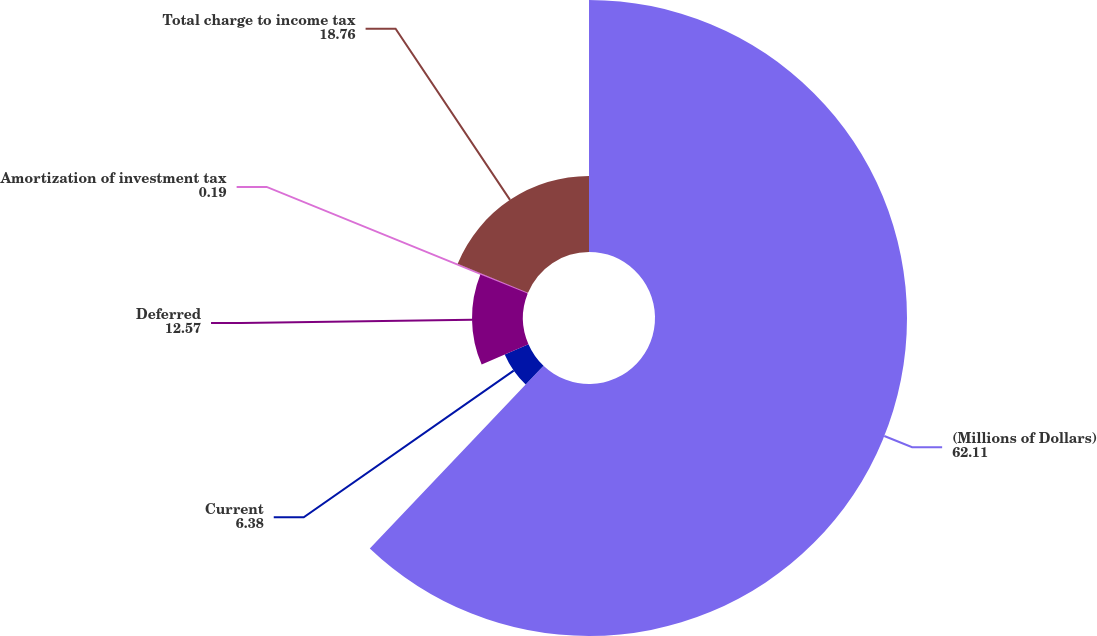Convert chart to OTSL. <chart><loc_0><loc_0><loc_500><loc_500><pie_chart><fcel>(Millions of Dollars)<fcel>Current<fcel>Deferred<fcel>Amortization of investment tax<fcel>Total charge to income tax<nl><fcel>62.11%<fcel>6.38%<fcel>12.57%<fcel>0.19%<fcel>18.76%<nl></chart> 